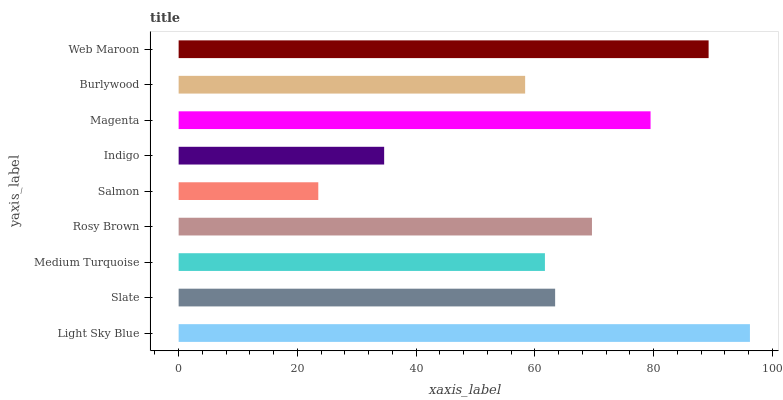Is Salmon the minimum?
Answer yes or no. Yes. Is Light Sky Blue the maximum?
Answer yes or no. Yes. Is Slate the minimum?
Answer yes or no. No. Is Slate the maximum?
Answer yes or no. No. Is Light Sky Blue greater than Slate?
Answer yes or no. Yes. Is Slate less than Light Sky Blue?
Answer yes or no. Yes. Is Slate greater than Light Sky Blue?
Answer yes or no. No. Is Light Sky Blue less than Slate?
Answer yes or no. No. Is Slate the high median?
Answer yes or no. Yes. Is Slate the low median?
Answer yes or no. Yes. Is Burlywood the high median?
Answer yes or no. No. Is Medium Turquoise the low median?
Answer yes or no. No. 